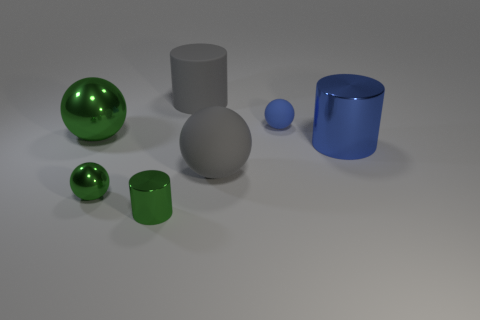What number of things are small rubber things or small purple metal things? In the image, there are a total of two small green rubber balls and no small purple metal things, making the count of objects that are either small rubber or small purple metal two. 